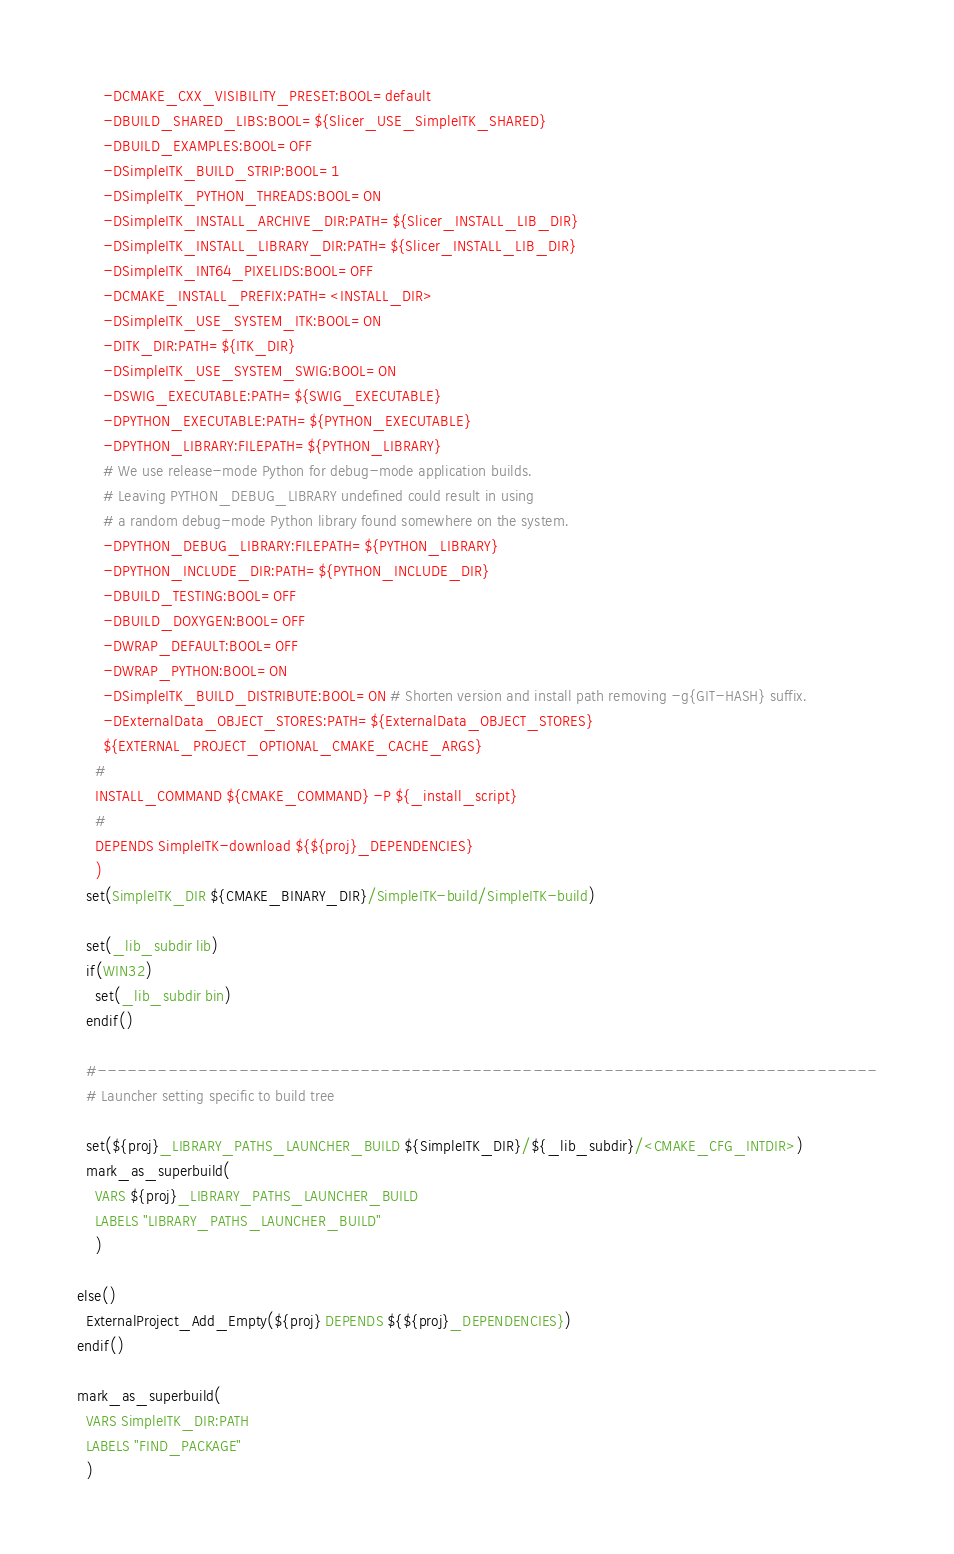<code> <loc_0><loc_0><loc_500><loc_500><_CMake_>      -DCMAKE_CXX_VISIBILITY_PRESET:BOOL=default
      -DBUILD_SHARED_LIBS:BOOL=${Slicer_USE_SimpleITK_SHARED}
      -DBUILD_EXAMPLES:BOOL=OFF
      -DSimpleITK_BUILD_STRIP:BOOL=1
      -DSimpleITK_PYTHON_THREADS:BOOL=ON
      -DSimpleITK_INSTALL_ARCHIVE_DIR:PATH=${Slicer_INSTALL_LIB_DIR}
      -DSimpleITK_INSTALL_LIBRARY_DIR:PATH=${Slicer_INSTALL_LIB_DIR}
      -DSimpleITK_INT64_PIXELIDS:BOOL=OFF
      -DCMAKE_INSTALL_PREFIX:PATH=<INSTALL_DIR>
      -DSimpleITK_USE_SYSTEM_ITK:BOOL=ON
      -DITK_DIR:PATH=${ITK_DIR}
      -DSimpleITK_USE_SYSTEM_SWIG:BOOL=ON
      -DSWIG_EXECUTABLE:PATH=${SWIG_EXECUTABLE}
      -DPYTHON_EXECUTABLE:PATH=${PYTHON_EXECUTABLE}
      -DPYTHON_LIBRARY:FILEPATH=${PYTHON_LIBRARY}
      # We use release-mode Python for debug-mode application builds.
      # Leaving PYTHON_DEBUG_LIBRARY undefined could result in using
      # a random debug-mode Python library found somewhere on the system.
      -DPYTHON_DEBUG_LIBRARY:FILEPATH=${PYTHON_LIBRARY}
      -DPYTHON_INCLUDE_DIR:PATH=${PYTHON_INCLUDE_DIR}
      -DBUILD_TESTING:BOOL=OFF
      -DBUILD_DOXYGEN:BOOL=OFF
      -DWRAP_DEFAULT:BOOL=OFF
      -DWRAP_PYTHON:BOOL=ON
      -DSimpleITK_BUILD_DISTRIBUTE:BOOL=ON # Shorten version and install path removing -g{GIT-HASH} suffix.
      -DExternalData_OBJECT_STORES:PATH=${ExternalData_OBJECT_STORES}
      ${EXTERNAL_PROJECT_OPTIONAL_CMAKE_CACHE_ARGS}
    #
    INSTALL_COMMAND ${CMAKE_COMMAND} -P ${_install_script}
    #
    DEPENDS SimpleITK-download ${${proj}_DEPENDENCIES}
    )
  set(SimpleITK_DIR ${CMAKE_BINARY_DIR}/SimpleITK-build/SimpleITK-build)

  set(_lib_subdir lib)
  if(WIN32)
    set(_lib_subdir bin)
  endif()

  #-----------------------------------------------------------------------------
  # Launcher setting specific to build tree

  set(${proj}_LIBRARY_PATHS_LAUNCHER_BUILD ${SimpleITK_DIR}/${_lib_subdir}/<CMAKE_CFG_INTDIR>)
  mark_as_superbuild(
    VARS ${proj}_LIBRARY_PATHS_LAUNCHER_BUILD
    LABELS "LIBRARY_PATHS_LAUNCHER_BUILD"
    )

else()
  ExternalProject_Add_Empty(${proj} DEPENDS ${${proj}_DEPENDENCIES})
endif()

mark_as_superbuild(
  VARS SimpleITK_DIR:PATH
  LABELS "FIND_PACKAGE"
  )
</code> 